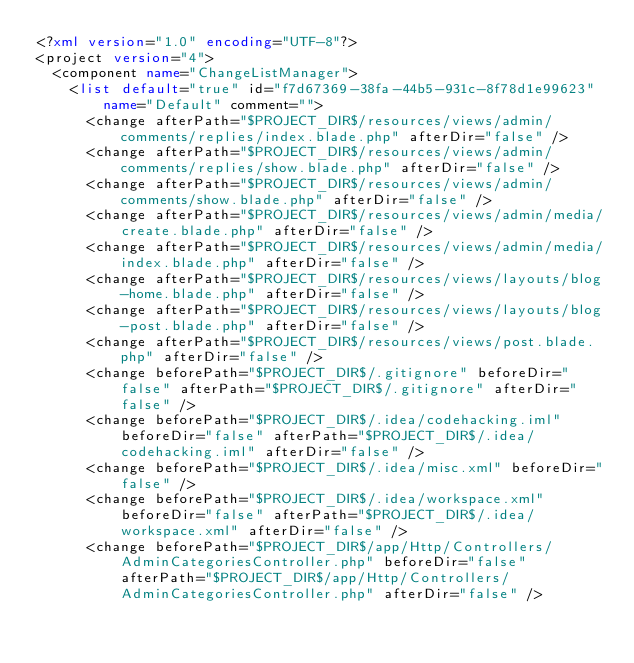Convert code to text. <code><loc_0><loc_0><loc_500><loc_500><_XML_><?xml version="1.0" encoding="UTF-8"?>
<project version="4">
  <component name="ChangeListManager">
    <list default="true" id="f7d67369-38fa-44b5-931c-8f78d1e99623" name="Default" comment="">
      <change afterPath="$PROJECT_DIR$/resources/views/admin/comments/replies/index.blade.php" afterDir="false" />
      <change afterPath="$PROJECT_DIR$/resources/views/admin/comments/replies/show.blade.php" afterDir="false" />
      <change afterPath="$PROJECT_DIR$/resources/views/admin/comments/show.blade.php" afterDir="false" />
      <change afterPath="$PROJECT_DIR$/resources/views/admin/media/create.blade.php" afterDir="false" />
      <change afterPath="$PROJECT_DIR$/resources/views/admin/media/index.blade.php" afterDir="false" />
      <change afterPath="$PROJECT_DIR$/resources/views/layouts/blog-home.blade.php" afterDir="false" />
      <change afterPath="$PROJECT_DIR$/resources/views/layouts/blog-post.blade.php" afterDir="false" />
      <change afterPath="$PROJECT_DIR$/resources/views/post.blade.php" afterDir="false" />
      <change beforePath="$PROJECT_DIR$/.gitignore" beforeDir="false" afterPath="$PROJECT_DIR$/.gitignore" afterDir="false" />
      <change beforePath="$PROJECT_DIR$/.idea/codehacking.iml" beforeDir="false" afterPath="$PROJECT_DIR$/.idea/codehacking.iml" afterDir="false" />
      <change beforePath="$PROJECT_DIR$/.idea/misc.xml" beforeDir="false" />
      <change beforePath="$PROJECT_DIR$/.idea/workspace.xml" beforeDir="false" afterPath="$PROJECT_DIR$/.idea/workspace.xml" afterDir="false" />
      <change beforePath="$PROJECT_DIR$/app/Http/Controllers/AdminCategoriesController.php" beforeDir="false" afterPath="$PROJECT_DIR$/app/Http/Controllers/AdminCategoriesController.php" afterDir="false" /></code> 